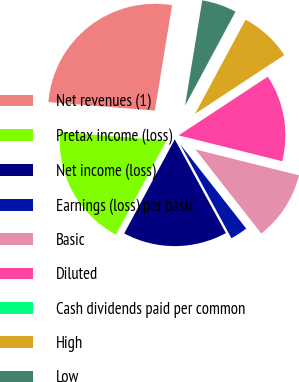Convert chart. <chart><loc_0><loc_0><loc_500><loc_500><pie_chart><fcel>Net revenues (1)<fcel>Pretax income (loss)<fcel>Net income (loss)<fcel>Earnings (loss) per basic<fcel>Basic<fcel>Diluted<fcel>Cash dividends paid per common<fcel>High<fcel>Low<nl><fcel>26.31%<fcel>18.42%<fcel>15.79%<fcel>2.63%<fcel>10.53%<fcel>13.16%<fcel>0.0%<fcel>7.9%<fcel>5.26%<nl></chart> 